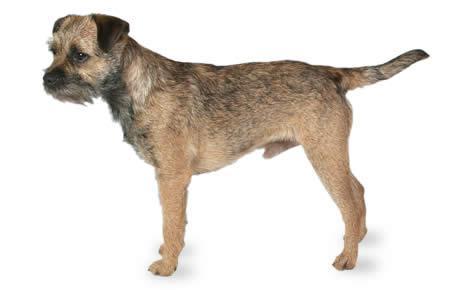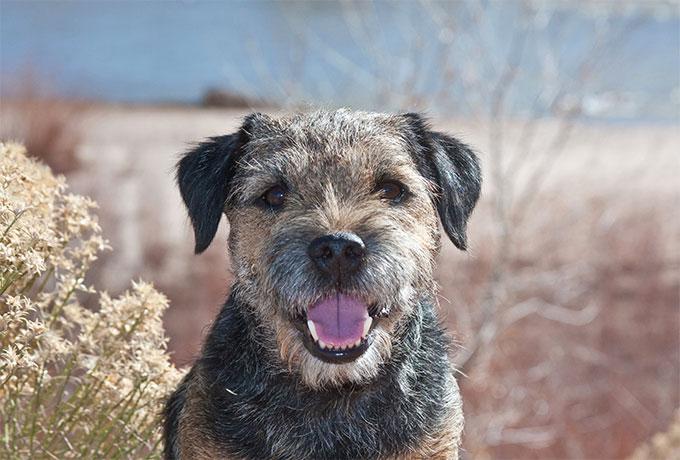The first image is the image on the left, the second image is the image on the right. Considering the images on both sides, is "The dog on the left image is facing left while the dog on the right image is facing directly towards the camera." valid? Answer yes or no. Yes. 